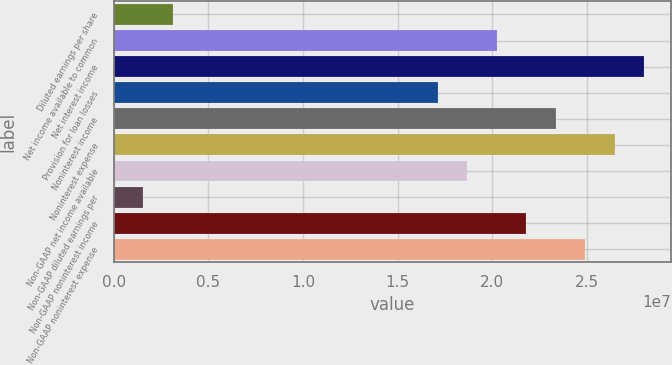Convert chart. <chart><loc_0><loc_0><loc_500><loc_500><bar_chart><fcel>Diluted earnings per share<fcel>Net income available to common<fcel>Net interest income<fcel>Provision for loan losses<fcel>Noninterest income<fcel>Noninterest expense<fcel>Non-GAAP net income available<fcel>Non-GAAP diluted earnings per<fcel>Non-GAAP noninterest income<fcel>Non-GAAP noninterest expense<nl><fcel>3.11376e+06<fcel>2.02394e+07<fcel>2.80238e+07<fcel>1.71257e+07<fcel>2.33532e+07<fcel>2.6467e+07<fcel>1.86826e+07<fcel>1.55688e+06<fcel>2.17963e+07<fcel>2.49101e+07<nl></chart> 